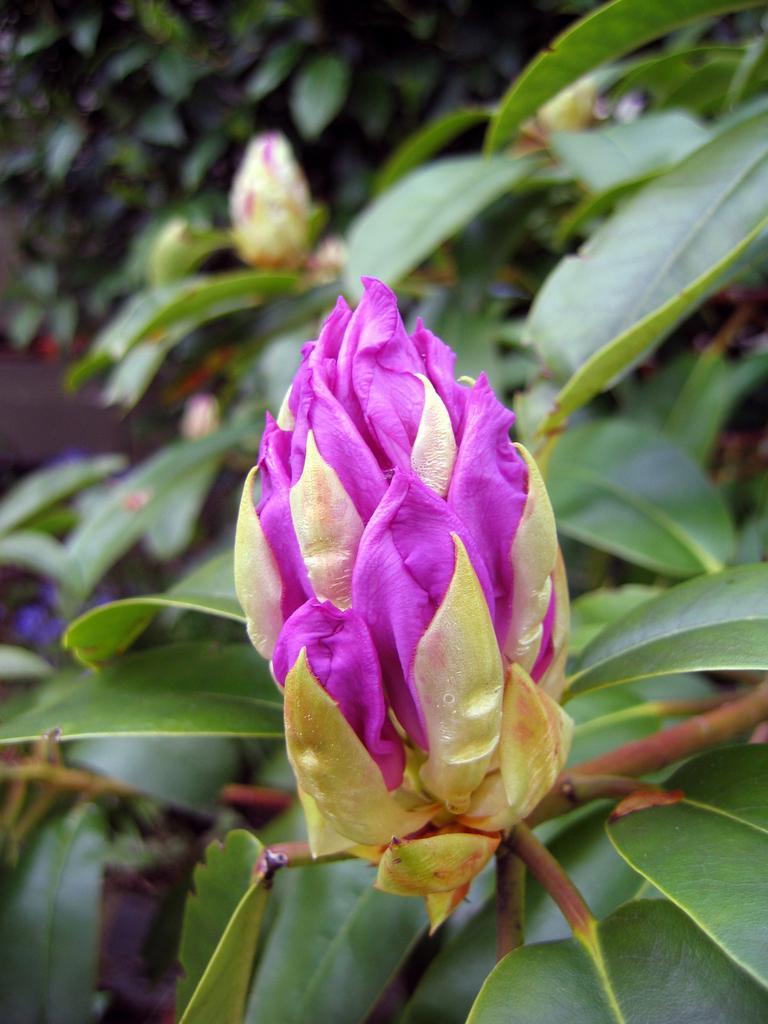Could you give a brief overview of what you see in this image? In the center of this picture we can see the flowers and the green leaves and some other objects. 